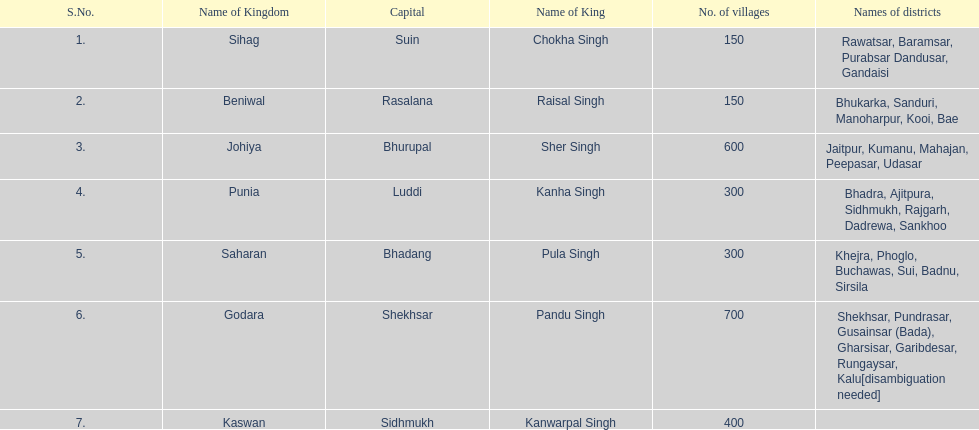I'm looking to parse the entire table for insights. Could you assist me with that? {'header': ['S.No.', 'Name of Kingdom', 'Capital', 'Name of King', 'No. of villages', 'Names of districts'], 'rows': [['1.', 'Sihag', 'Suin', 'Chokha Singh', '150', 'Rawatsar, Baramsar, Purabsar Dandusar, Gandaisi'], ['2.', 'Beniwal', 'Rasalana', 'Raisal Singh', '150', 'Bhukarka, Sanduri, Manoharpur, Kooi, Bae'], ['3.', 'Johiya', 'Bhurupal', 'Sher Singh', '600', 'Jaitpur, Kumanu, Mahajan, Peepasar, Udasar'], ['4.', 'Punia', 'Luddi', 'Kanha Singh', '300', 'Bhadra, Ajitpura, Sidhmukh, Rajgarh, Dadrewa, Sankhoo'], ['5.', 'Saharan', 'Bhadang', 'Pula Singh', '300', 'Khejra, Phoglo, Buchawas, Sui, Badnu, Sirsila'], ['6.', 'Godara', 'Shekhsar', 'Pandu Singh', '700', 'Shekhsar, Pundrasar, Gusainsar (Bada), Gharsisar, Garibdesar, Rungaysar, Kalu[disambiguation needed]'], ['7.', 'Kaswan', 'Sidhmukh', 'Kanwarpal Singh', '400', '']]} Which kingdom has the most villages? Godara. 